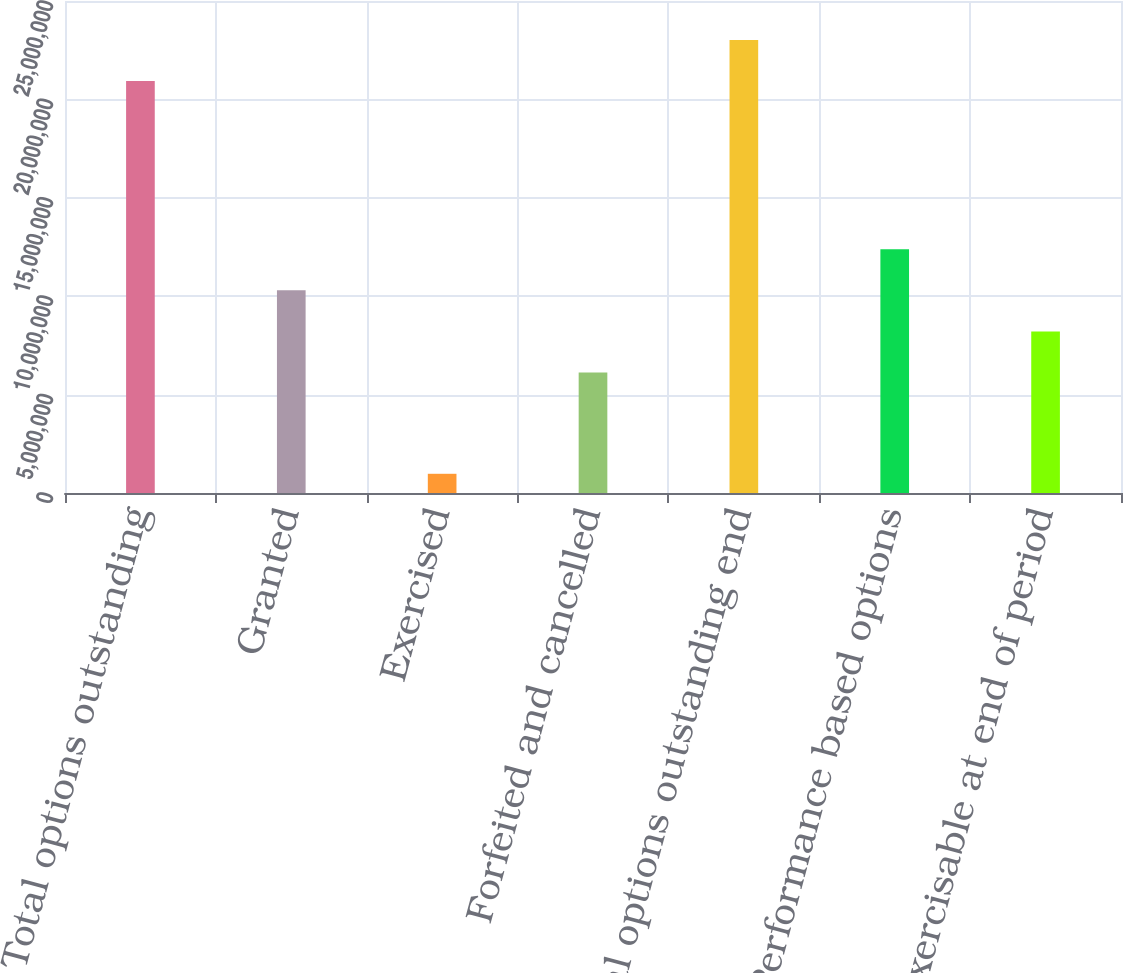Convert chart. <chart><loc_0><loc_0><loc_500><loc_500><bar_chart><fcel>Total options outstanding<fcel>Granted<fcel>Exercised<fcel>Forfeited and cancelled<fcel>Total options outstanding end<fcel>Performance based options<fcel>Exercisable at end of period<nl><fcel>2.09384e+07<fcel>1.02969e+07<fcel>976187<fcel>6.12503e+06<fcel>2.30244e+07<fcel>1.23829e+07<fcel>8.21098e+06<nl></chart> 